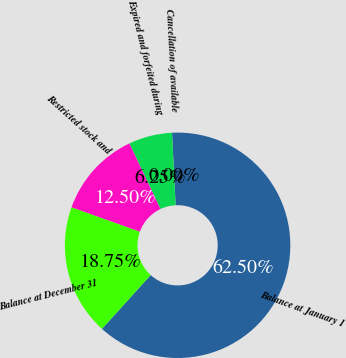Convert chart to OTSL. <chart><loc_0><loc_0><loc_500><loc_500><pie_chart><fcel>Balance at January 1<fcel>Cancellation of available<fcel>Expired and forfeited during<fcel>Restricted stock and<fcel>Balance at December 31<nl><fcel>62.5%<fcel>0.0%<fcel>6.25%<fcel>12.5%<fcel>18.75%<nl></chart> 